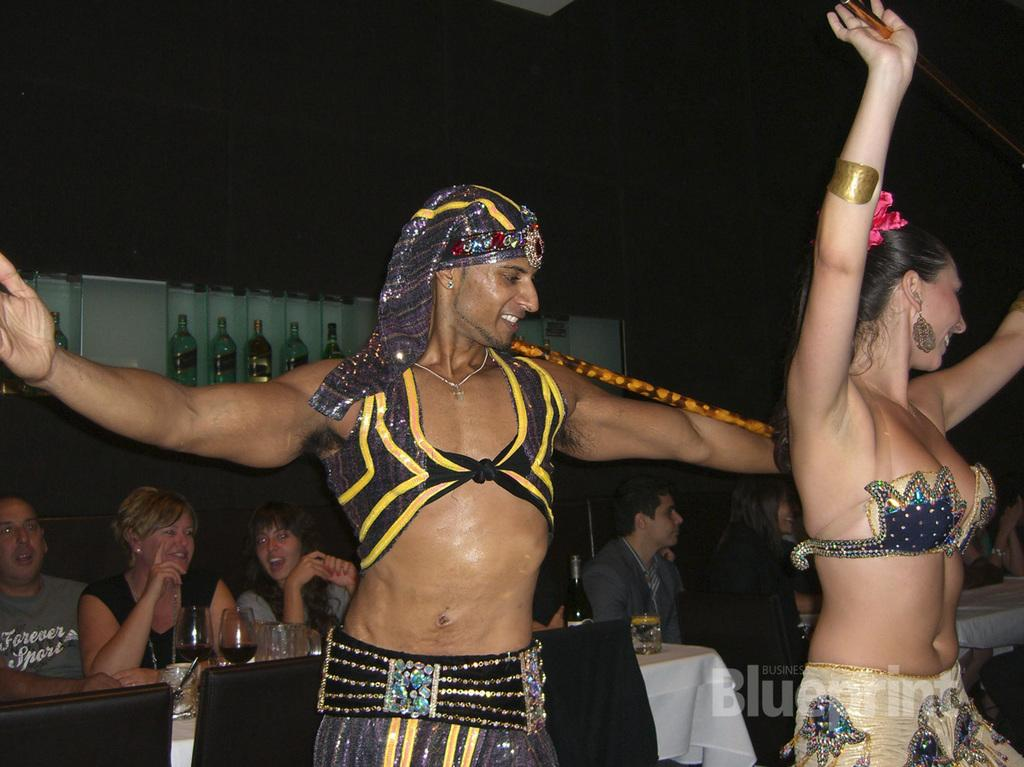Who are the two people in the image? There is a man and a woman in the image. What are the man and woman doing in the image? The man and woman are dancing. What can be seen in the background of the image? There are people, a table, glasses, chairs, cloth, and bottles in the background of the image. Is there any text visible in the background? Yes, there is a text in the background of the image. How many ducks are present in the image? There are no ducks present in the image. What type of order is being followed by the stomach in the image? There is no stomach present in the image, so it is not possible to determine any order being followed. 